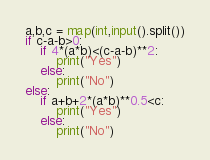<code> <loc_0><loc_0><loc_500><loc_500><_Python_>a,b,c = map(int,input().split())
if c-a-b>0:
    if 4*(a*b)<(c-a-b)**2:
        print("Yes")
    else:
        print("No")
else:
    if a+b+2*(a*b)**0.5<c:
        print("Yes")
    else:
        print("No")</code> 